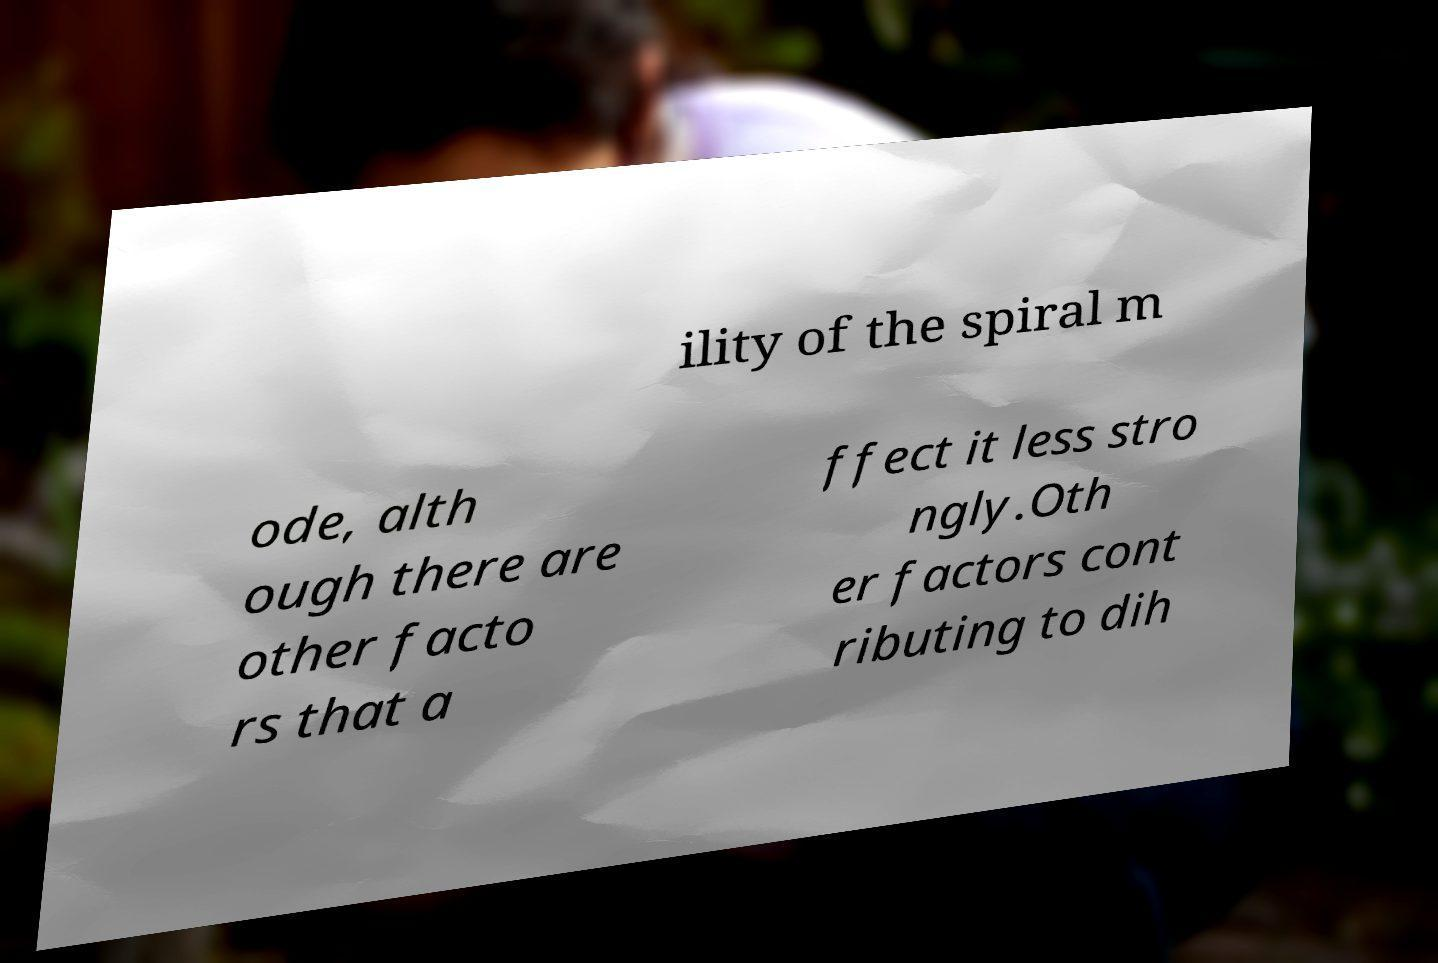Could you assist in decoding the text presented in this image and type it out clearly? ility of the spiral m ode, alth ough there are other facto rs that a ffect it less stro ngly.Oth er factors cont ributing to dih 